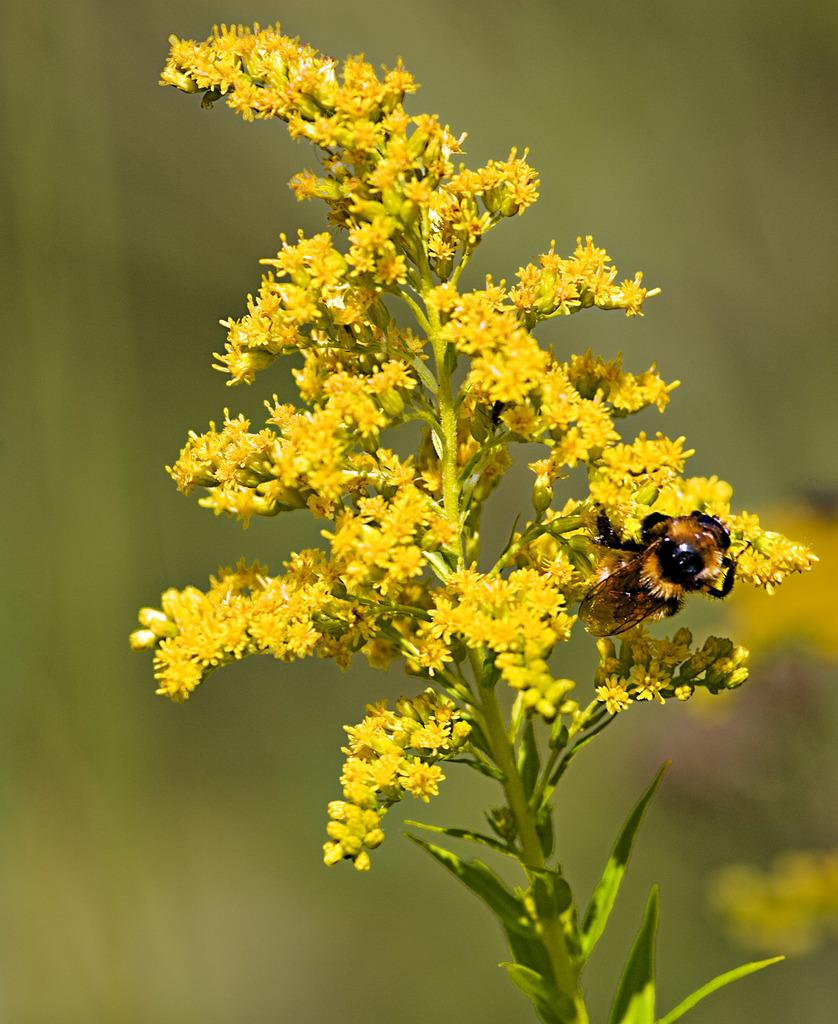What type of living organism can be seen in the image? There is a plant in the image. What specific feature of the plant is visible? The plant has flowers. Are there any other living organisms interacting with the plant in the image? Yes, there is a bee present on the flowers. What is the price of the bikes in the image? There are no bikes present in the image, so it is not possible to determine the price. 